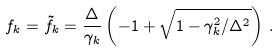<formula> <loc_0><loc_0><loc_500><loc_500>f _ { k } = \tilde { f } _ { k } = \frac { \Delta } { \gamma _ { k } } \left ( - 1 + \sqrt { 1 - \gamma _ { k } ^ { 2 } / \Delta ^ { 2 } } \right ) \, .</formula> 